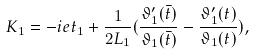Convert formula to latex. <formula><loc_0><loc_0><loc_500><loc_500>K _ { 1 } = - i e t _ { 1 } + \frac { 1 } { 2 L _ { 1 } } ( \frac { \vartheta _ { 1 } ^ { \prime } ( \bar { t } ) } { \vartheta _ { 1 } ( \bar { t } ) } - \frac { \vartheta _ { 1 } ^ { \prime } ( t ) } { \vartheta _ { 1 } ( t ) } ) ,</formula> 